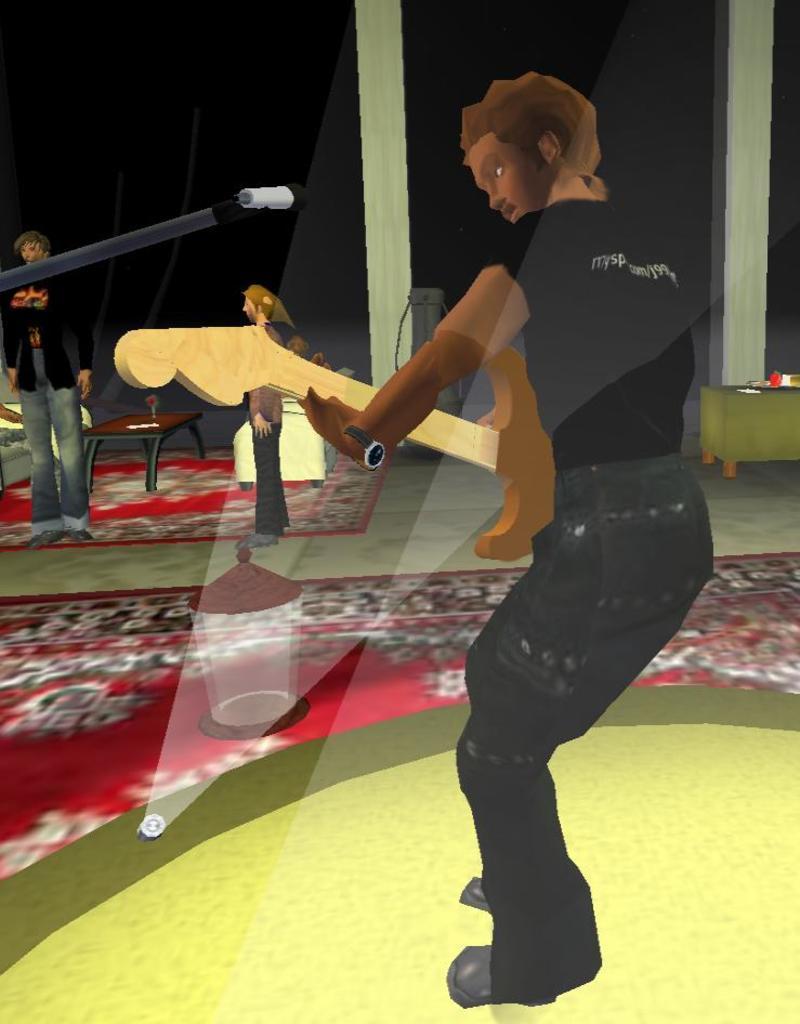Describe this image in one or two sentences. This is an animated image, in this image there pillars towards the top of the image, there are tables, there are objects on the tables, there are couches, there are persons sitting on the couches, there are three men standing, there is a man playing a musical instrument, there is a carpet on the floor, there is an object on the carpet, there is a stage towards the bottom of the image, there is a light on the stage, there is a stand towards the left of the image, there is a microphone, the background of the image is dark. 